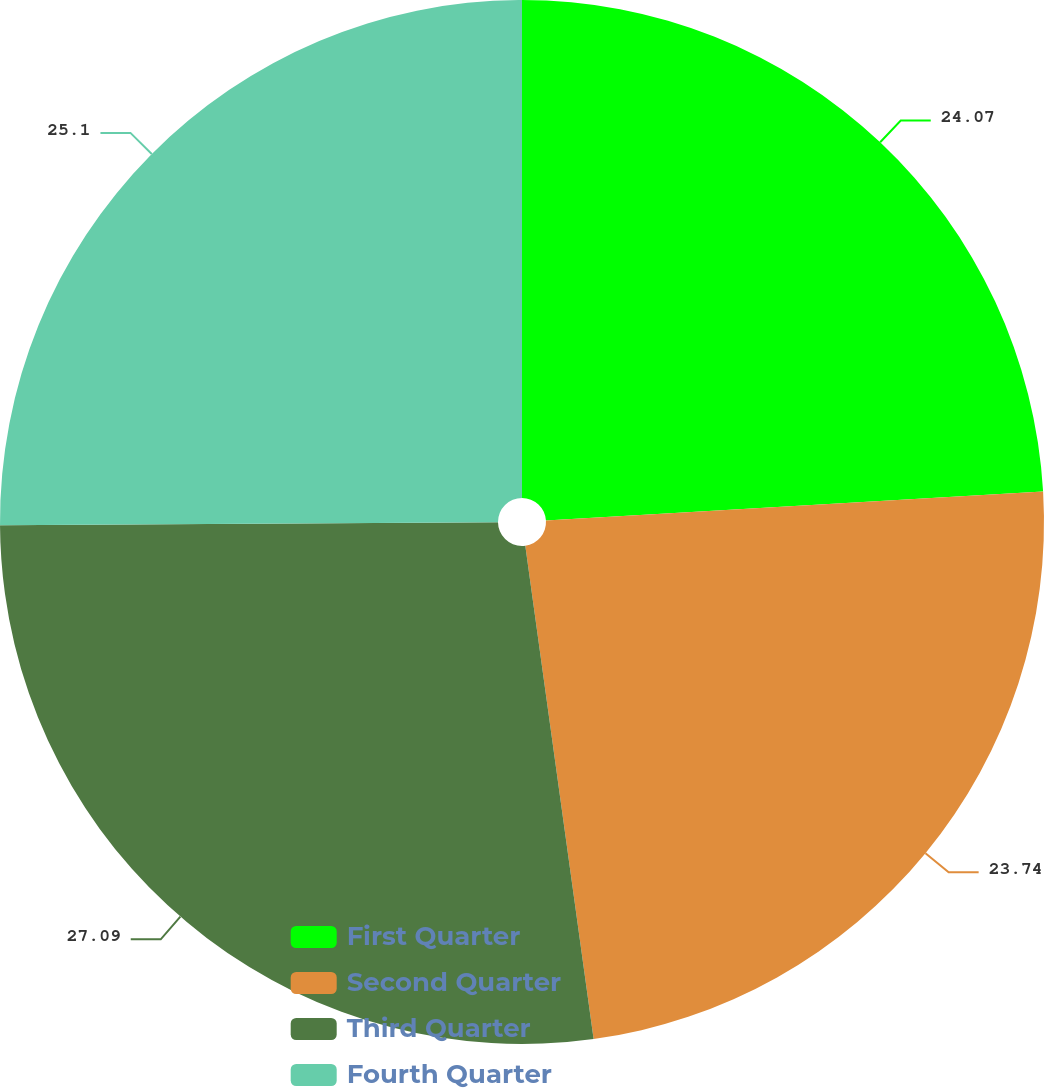Convert chart to OTSL. <chart><loc_0><loc_0><loc_500><loc_500><pie_chart><fcel>First Quarter<fcel>Second Quarter<fcel>Third Quarter<fcel>Fourth Quarter<nl><fcel>24.07%<fcel>23.74%<fcel>27.09%<fcel>25.1%<nl></chart> 